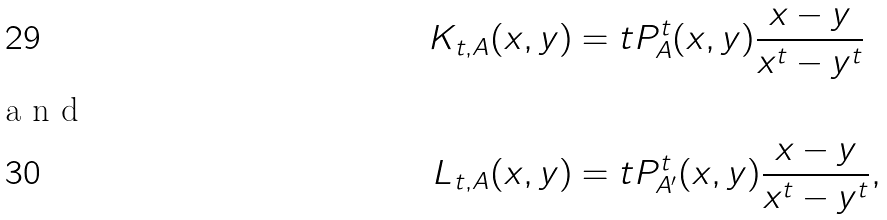Convert formula to latex. <formula><loc_0><loc_0><loc_500><loc_500>K _ { t , A } ( x , y ) & = t P _ { A } ^ { t } ( x , y ) \frac { x - y } { x ^ { t } - y ^ { t } } \\ \intertext { a n d } L _ { t , A } ( x , y ) & = t P _ { A ^ { \prime } } ^ { t } ( x , y ) \frac { x - y } { x ^ { t } - y ^ { t } } ,</formula> 